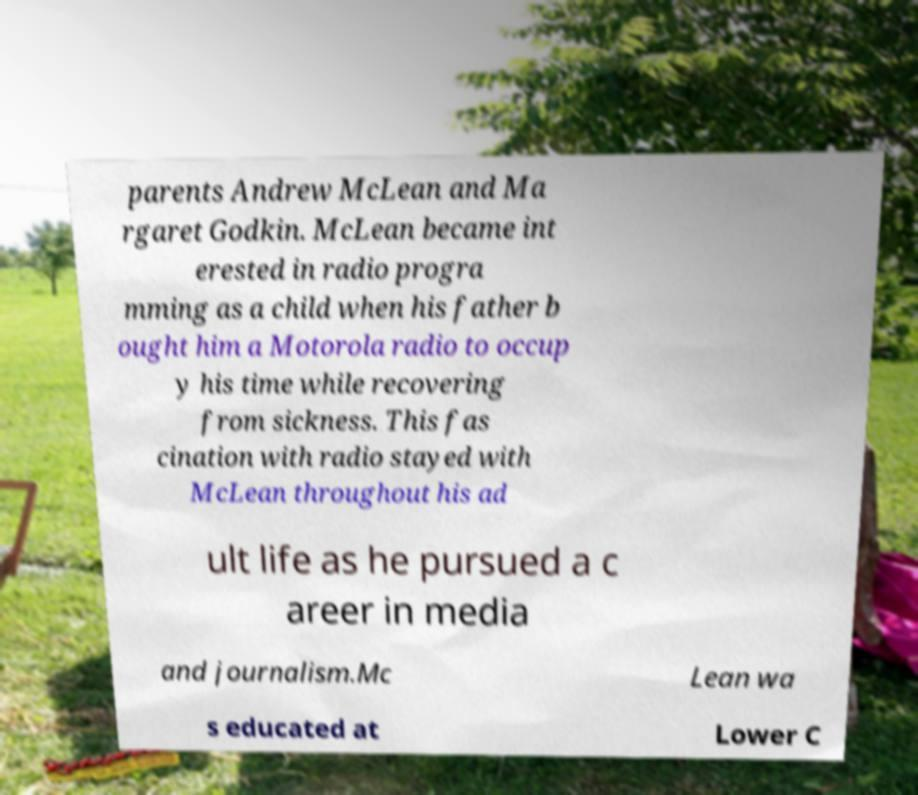Could you extract and type out the text from this image? parents Andrew McLean and Ma rgaret Godkin. McLean became int erested in radio progra mming as a child when his father b ought him a Motorola radio to occup y his time while recovering from sickness. This fas cination with radio stayed with McLean throughout his ad ult life as he pursued a c areer in media and journalism.Mc Lean wa s educated at Lower C 